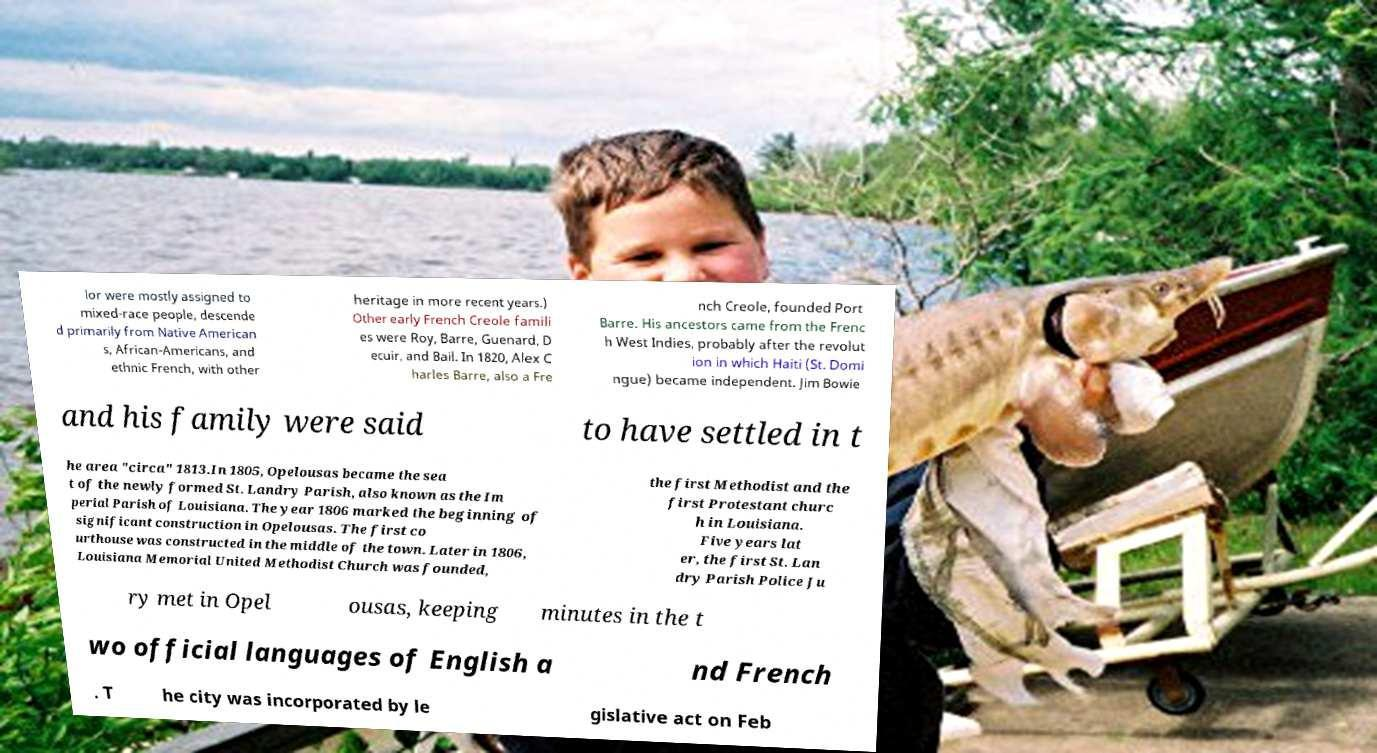There's text embedded in this image that I need extracted. Can you transcribe it verbatim? lor were mostly assigned to mixed-race people, descende d primarily from Native American s, African-Americans, and ethnic French, with other heritage in more recent years.) Other early French Creole famili es were Roy, Barre, Guenard, D ecuir, and Bail. In 1820, Alex C harles Barre, also a Fre nch Creole, founded Port Barre. His ancestors came from the Frenc h West Indies, probably after the revolut ion in which Haiti (St. Domi ngue) became independent. Jim Bowie and his family were said to have settled in t he area "circa" 1813.In 1805, Opelousas became the sea t of the newly formed St. Landry Parish, also known as the Im perial Parish of Louisiana. The year 1806 marked the beginning of significant construction in Opelousas. The first co urthouse was constructed in the middle of the town. Later in 1806, Louisiana Memorial United Methodist Church was founded, the first Methodist and the first Protestant churc h in Louisiana. Five years lat er, the first St. Lan dry Parish Police Ju ry met in Opel ousas, keeping minutes in the t wo official languages of English a nd French . T he city was incorporated by le gislative act on Feb 